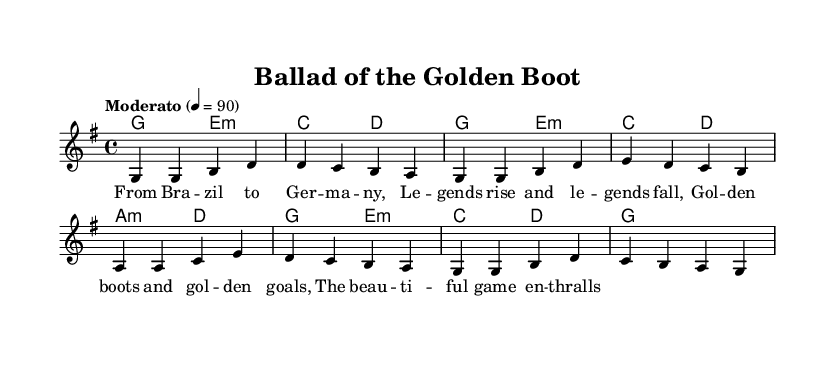What is the key signature of this music? The key signature indicates G major, which has one sharp (F#). This can be identified by looking at the key signature at the beginning of the score, which shows one sharp.
Answer: G major What is the time signature of this music? The time signature is 4/4, which is seen at the beginning of the score, indicating that there are four beats in each measure and the quarter note gets one beat.
Answer: 4/4 What is the tempo marking for this piece? The tempo marking is "Moderato," and it is indicated in the tempo instruction above the staff, suggesting a moderate speed for the performance.
Answer: Moderato How many measures are in the melody? To find the total number of measures, you can count the individual measures in the melody line, which includes eight measures total.
Answer: Eight What is the structure of the lyrics in this folk song? The lyrics feature four lines that describe the journey and emotions tied to soccer legends, formatted into a stanza. The clear four-line structure gives it a traditional folk song feel.
Answer: Four lines What kind of chords are used in the harmonies? The chords are primarily based on major and minor harmonies; specifically, they mix major chords with E minor and A minor chords, which is typical for folk songs to create a sense of storytelling.
Answer: Major and minor What thematic content is reflected in the lyrics? The lyrics celebrate soccer legends and their journeys from Brazil to Germany, referencing 'golden boots' and the beauty of the game, which evokes emotions associated with international football.
Answer: Soccer legends 